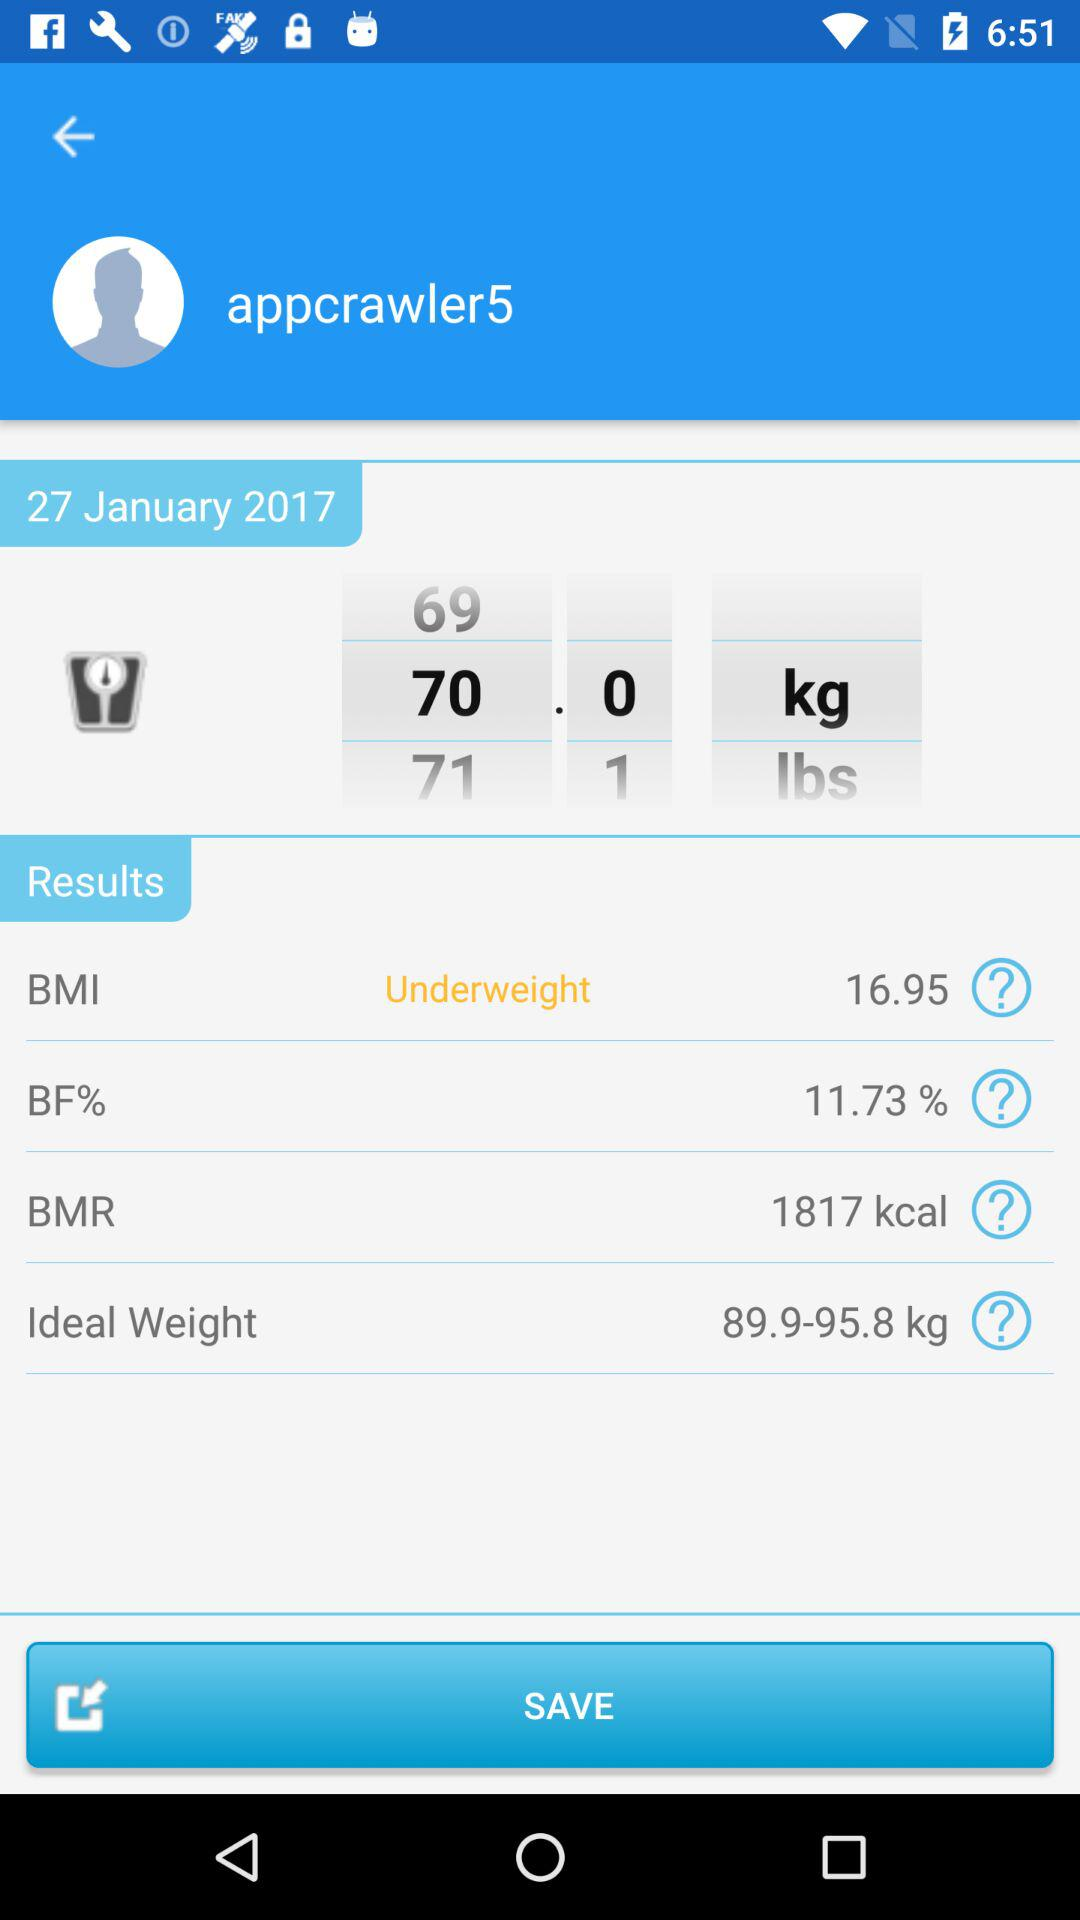What is the BF%? The BF% is 11.73. 